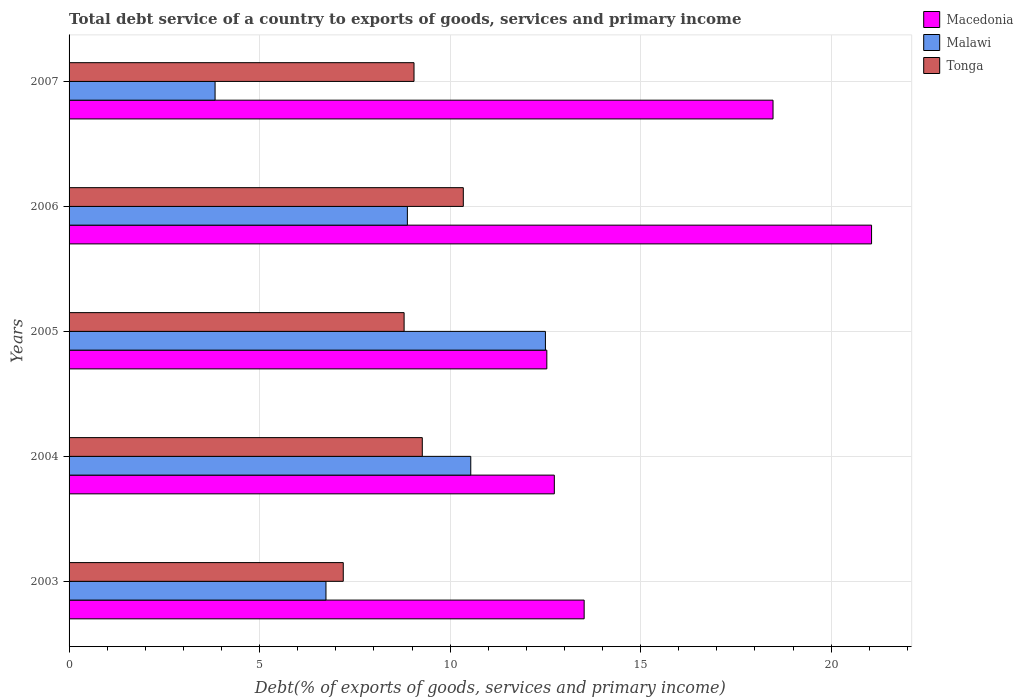Are the number of bars per tick equal to the number of legend labels?
Provide a succinct answer. Yes. How many bars are there on the 1st tick from the top?
Keep it short and to the point. 3. How many bars are there on the 1st tick from the bottom?
Your response must be concise. 3. In how many cases, is the number of bars for a given year not equal to the number of legend labels?
Your response must be concise. 0. What is the total debt service in Tonga in 2007?
Offer a very short reply. 9.05. Across all years, what is the maximum total debt service in Tonga?
Provide a succinct answer. 10.35. Across all years, what is the minimum total debt service in Malawi?
Your answer should be very brief. 3.83. In which year was the total debt service in Malawi maximum?
Give a very brief answer. 2005. What is the total total debt service in Macedonia in the graph?
Keep it short and to the point. 78.33. What is the difference between the total debt service in Malawi in 2004 and that in 2005?
Provide a succinct answer. -1.96. What is the difference between the total debt service in Malawi in 2005 and the total debt service in Tonga in 2007?
Your answer should be very brief. 3.45. What is the average total debt service in Tonga per year?
Your answer should be compact. 8.93. In the year 2007, what is the difference between the total debt service in Tonga and total debt service in Macedonia?
Give a very brief answer. -9.42. In how many years, is the total debt service in Tonga greater than 6 %?
Provide a succinct answer. 5. What is the ratio of the total debt service in Macedonia in 2004 to that in 2005?
Make the answer very short. 1.02. What is the difference between the highest and the second highest total debt service in Macedonia?
Ensure brevity in your answer.  2.59. What is the difference between the highest and the lowest total debt service in Macedonia?
Keep it short and to the point. 8.52. In how many years, is the total debt service in Macedonia greater than the average total debt service in Macedonia taken over all years?
Make the answer very short. 2. What does the 1st bar from the top in 2006 represents?
Your answer should be compact. Tonga. What does the 1st bar from the bottom in 2003 represents?
Offer a very short reply. Macedonia. Is it the case that in every year, the sum of the total debt service in Tonga and total debt service in Malawi is greater than the total debt service in Macedonia?
Offer a terse response. No. Are all the bars in the graph horizontal?
Ensure brevity in your answer.  Yes. What is the difference between two consecutive major ticks on the X-axis?
Make the answer very short. 5. Are the values on the major ticks of X-axis written in scientific E-notation?
Provide a short and direct response. No. Does the graph contain any zero values?
Provide a succinct answer. No. Does the graph contain grids?
Offer a very short reply. Yes. How are the legend labels stacked?
Offer a very short reply. Vertical. What is the title of the graph?
Give a very brief answer. Total debt service of a country to exports of goods, services and primary income. What is the label or title of the X-axis?
Your answer should be compact. Debt(% of exports of goods, services and primary income). What is the Debt(% of exports of goods, services and primary income) in Macedonia in 2003?
Keep it short and to the point. 13.52. What is the Debt(% of exports of goods, services and primary income) of Malawi in 2003?
Your response must be concise. 6.74. What is the Debt(% of exports of goods, services and primary income) of Tonga in 2003?
Make the answer very short. 7.2. What is the Debt(% of exports of goods, services and primary income) in Macedonia in 2004?
Your response must be concise. 12.74. What is the Debt(% of exports of goods, services and primary income) in Malawi in 2004?
Offer a terse response. 10.54. What is the Debt(% of exports of goods, services and primary income) in Tonga in 2004?
Keep it short and to the point. 9.27. What is the Debt(% of exports of goods, services and primary income) in Macedonia in 2005?
Your answer should be compact. 12.54. What is the Debt(% of exports of goods, services and primary income) of Malawi in 2005?
Offer a terse response. 12.5. What is the Debt(% of exports of goods, services and primary income) of Tonga in 2005?
Provide a short and direct response. 8.79. What is the Debt(% of exports of goods, services and primary income) in Macedonia in 2006?
Provide a short and direct response. 21.06. What is the Debt(% of exports of goods, services and primary income) in Malawi in 2006?
Give a very brief answer. 8.88. What is the Debt(% of exports of goods, services and primary income) of Tonga in 2006?
Your answer should be compact. 10.35. What is the Debt(% of exports of goods, services and primary income) in Macedonia in 2007?
Keep it short and to the point. 18.47. What is the Debt(% of exports of goods, services and primary income) of Malawi in 2007?
Your response must be concise. 3.83. What is the Debt(% of exports of goods, services and primary income) in Tonga in 2007?
Provide a succinct answer. 9.05. Across all years, what is the maximum Debt(% of exports of goods, services and primary income) of Macedonia?
Offer a very short reply. 21.06. Across all years, what is the maximum Debt(% of exports of goods, services and primary income) of Malawi?
Ensure brevity in your answer.  12.5. Across all years, what is the maximum Debt(% of exports of goods, services and primary income) in Tonga?
Keep it short and to the point. 10.35. Across all years, what is the minimum Debt(% of exports of goods, services and primary income) in Macedonia?
Offer a terse response. 12.54. Across all years, what is the minimum Debt(% of exports of goods, services and primary income) in Malawi?
Keep it short and to the point. 3.83. Across all years, what is the minimum Debt(% of exports of goods, services and primary income) in Tonga?
Make the answer very short. 7.2. What is the total Debt(% of exports of goods, services and primary income) of Macedonia in the graph?
Give a very brief answer. 78.33. What is the total Debt(% of exports of goods, services and primary income) in Malawi in the graph?
Provide a succinct answer. 42.5. What is the total Debt(% of exports of goods, services and primary income) in Tonga in the graph?
Ensure brevity in your answer.  44.66. What is the difference between the Debt(% of exports of goods, services and primary income) of Macedonia in 2003 and that in 2004?
Offer a terse response. 0.78. What is the difference between the Debt(% of exports of goods, services and primary income) of Malawi in 2003 and that in 2004?
Give a very brief answer. -3.8. What is the difference between the Debt(% of exports of goods, services and primary income) in Tonga in 2003 and that in 2004?
Offer a very short reply. -2.07. What is the difference between the Debt(% of exports of goods, services and primary income) of Macedonia in 2003 and that in 2005?
Offer a very short reply. 0.98. What is the difference between the Debt(% of exports of goods, services and primary income) of Malawi in 2003 and that in 2005?
Ensure brevity in your answer.  -5.76. What is the difference between the Debt(% of exports of goods, services and primary income) in Tonga in 2003 and that in 2005?
Offer a terse response. -1.6. What is the difference between the Debt(% of exports of goods, services and primary income) of Macedonia in 2003 and that in 2006?
Offer a terse response. -7.54. What is the difference between the Debt(% of exports of goods, services and primary income) of Malawi in 2003 and that in 2006?
Provide a short and direct response. -2.14. What is the difference between the Debt(% of exports of goods, services and primary income) of Tonga in 2003 and that in 2006?
Keep it short and to the point. -3.15. What is the difference between the Debt(% of exports of goods, services and primary income) in Macedonia in 2003 and that in 2007?
Offer a very short reply. -4.96. What is the difference between the Debt(% of exports of goods, services and primary income) of Malawi in 2003 and that in 2007?
Make the answer very short. 2.91. What is the difference between the Debt(% of exports of goods, services and primary income) in Tonga in 2003 and that in 2007?
Your response must be concise. -1.86. What is the difference between the Debt(% of exports of goods, services and primary income) of Macedonia in 2004 and that in 2005?
Provide a short and direct response. 0.2. What is the difference between the Debt(% of exports of goods, services and primary income) of Malawi in 2004 and that in 2005?
Ensure brevity in your answer.  -1.96. What is the difference between the Debt(% of exports of goods, services and primary income) in Tonga in 2004 and that in 2005?
Give a very brief answer. 0.48. What is the difference between the Debt(% of exports of goods, services and primary income) of Macedonia in 2004 and that in 2006?
Your answer should be compact. -8.33. What is the difference between the Debt(% of exports of goods, services and primary income) of Malawi in 2004 and that in 2006?
Give a very brief answer. 1.66. What is the difference between the Debt(% of exports of goods, services and primary income) in Tonga in 2004 and that in 2006?
Offer a very short reply. -1.08. What is the difference between the Debt(% of exports of goods, services and primary income) of Macedonia in 2004 and that in 2007?
Offer a terse response. -5.74. What is the difference between the Debt(% of exports of goods, services and primary income) of Malawi in 2004 and that in 2007?
Provide a succinct answer. 6.71. What is the difference between the Debt(% of exports of goods, services and primary income) of Tonga in 2004 and that in 2007?
Give a very brief answer. 0.22. What is the difference between the Debt(% of exports of goods, services and primary income) in Macedonia in 2005 and that in 2006?
Your answer should be very brief. -8.52. What is the difference between the Debt(% of exports of goods, services and primary income) of Malawi in 2005 and that in 2006?
Your answer should be very brief. 3.62. What is the difference between the Debt(% of exports of goods, services and primary income) in Tonga in 2005 and that in 2006?
Provide a short and direct response. -1.55. What is the difference between the Debt(% of exports of goods, services and primary income) of Macedonia in 2005 and that in 2007?
Offer a terse response. -5.94. What is the difference between the Debt(% of exports of goods, services and primary income) of Malawi in 2005 and that in 2007?
Make the answer very short. 8.67. What is the difference between the Debt(% of exports of goods, services and primary income) of Tonga in 2005 and that in 2007?
Give a very brief answer. -0.26. What is the difference between the Debt(% of exports of goods, services and primary income) of Macedonia in 2006 and that in 2007?
Ensure brevity in your answer.  2.59. What is the difference between the Debt(% of exports of goods, services and primary income) of Malawi in 2006 and that in 2007?
Offer a terse response. 5.05. What is the difference between the Debt(% of exports of goods, services and primary income) in Tonga in 2006 and that in 2007?
Provide a short and direct response. 1.29. What is the difference between the Debt(% of exports of goods, services and primary income) in Macedonia in 2003 and the Debt(% of exports of goods, services and primary income) in Malawi in 2004?
Offer a very short reply. 2.98. What is the difference between the Debt(% of exports of goods, services and primary income) of Macedonia in 2003 and the Debt(% of exports of goods, services and primary income) of Tonga in 2004?
Provide a succinct answer. 4.25. What is the difference between the Debt(% of exports of goods, services and primary income) in Malawi in 2003 and the Debt(% of exports of goods, services and primary income) in Tonga in 2004?
Offer a terse response. -2.53. What is the difference between the Debt(% of exports of goods, services and primary income) in Macedonia in 2003 and the Debt(% of exports of goods, services and primary income) in Malawi in 2005?
Give a very brief answer. 1.02. What is the difference between the Debt(% of exports of goods, services and primary income) in Macedonia in 2003 and the Debt(% of exports of goods, services and primary income) in Tonga in 2005?
Offer a terse response. 4.73. What is the difference between the Debt(% of exports of goods, services and primary income) in Malawi in 2003 and the Debt(% of exports of goods, services and primary income) in Tonga in 2005?
Provide a short and direct response. -2.05. What is the difference between the Debt(% of exports of goods, services and primary income) of Macedonia in 2003 and the Debt(% of exports of goods, services and primary income) of Malawi in 2006?
Ensure brevity in your answer.  4.64. What is the difference between the Debt(% of exports of goods, services and primary income) in Macedonia in 2003 and the Debt(% of exports of goods, services and primary income) in Tonga in 2006?
Your response must be concise. 3.17. What is the difference between the Debt(% of exports of goods, services and primary income) of Malawi in 2003 and the Debt(% of exports of goods, services and primary income) of Tonga in 2006?
Offer a very short reply. -3.6. What is the difference between the Debt(% of exports of goods, services and primary income) of Macedonia in 2003 and the Debt(% of exports of goods, services and primary income) of Malawi in 2007?
Offer a very short reply. 9.69. What is the difference between the Debt(% of exports of goods, services and primary income) in Macedonia in 2003 and the Debt(% of exports of goods, services and primary income) in Tonga in 2007?
Keep it short and to the point. 4.46. What is the difference between the Debt(% of exports of goods, services and primary income) in Malawi in 2003 and the Debt(% of exports of goods, services and primary income) in Tonga in 2007?
Your answer should be compact. -2.31. What is the difference between the Debt(% of exports of goods, services and primary income) of Macedonia in 2004 and the Debt(% of exports of goods, services and primary income) of Malawi in 2005?
Offer a very short reply. 0.23. What is the difference between the Debt(% of exports of goods, services and primary income) of Macedonia in 2004 and the Debt(% of exports of goods, services and primary income) of Tonga in 2005?
Keep it short and to the point. 3.94. What is the difference between the Debt(% of exports of goods, services and primary income) of Malawi in 2004 and the Debt(% of exports of goods, services and primary income) of Tonga in 2005?
Give a very brief answer. 1.75. What is the difference between the Debt(% of exports of goods, services and primary income) in Macedonia in 2004 and the Debt(% of exports of goods, services and primary income) in Malawi in 2006?
Give a very brief answer. 3.86. What is the difference between the Debt(% of exports of goods, services and primary income) of Macedonia in 2004 and the Debt(% of exports of goods, services and primary income) of Tonga in 2006?
Give a very brief answer. 2.39. What is the difference between the Debt(% of exports of goods, services and primary income) in Malawi in 2004 and the Debt(% of exports of goods, services and primary income) in Tonga in 2006?
Your response must be concise. 0.2. What is the difference between the Debt(% of exports of goods, services and primary income) of Macedonia in 2004 and the Debt(% of exports of goods, services and primary income) of Malawi in 2007?
Ensure brevity in your answer.  8.9. What is the difference between the Debt(% of exports of goods, services and primary income) of Macedonia in 2004 and the Debt(% of exports of goods, services and primary income) of Tonga in 2007?
Make the answer very short. 3.68. What is the difference between the Debt(% of exports of goods, services and primary income) in Malawi in 2004 and the Debt(% of exports of goods, services and primary income) in Tonga in 2007?
Offer a very short reply. 1.49. What is the difference between the Debt(% of exports of goods, services and primary income) of Macedonia in 2005 and the Debt(% of exports of goods, services and primary income) of Malawi in 2006?
Your answer should be compact. 3.66. What is the difference between the Debt(% of exports of goods, services and primary income) in Macedonia in 2005 and the Debt(% of exports of goods, services and primary income) in Tonga in 2006?
Offer a terse response. 2.19. What is the difference between the Debt(% of exports of goods, services and primary income) in Malawi in 2005 and the Debt(% of exports of goods, services and primary income) in Tonga in 2006?
Make the answer very short. 2.15. What is the difference between the Debt(% of exports of goods, services and primary income) in Macedonia in 2005 and the Debt(% of exports of goods, services and primary income) in Malawi in 2007?
Provide a succinct answer. 8.71. What is the difference between the Debt(% of exports of goods, services and primary income) in Macedonia in 2005 and the Debt(% of exports of goods, services and primary income) in Tonga in 2007?
Provide a short and direct response. 3.49. What is the difference between the Debt(% of exports of goods, services and primary income) of Malawi in 2005 and the Debt(% of exports of goods, services and primary income) of Tonga in 2007?
Your answer should be compact. 3.45. What is the difference between the Debt(% of exports of goods, services and primary income) in Macedonia in 2006 and the Debt(% of exports of goods, services and primary income) in Malawi in 2007?
Offer a very short reply. 17.23. What is the difference between the Debt(% of exports of goods, services and primary income) in Macedonia in 2006 and the Debt(% of exports of goods, services and primary income) in Tonga in 2007?
Your answer should be very brief. 12.01. What is the difference between the Debt(% of exports of goods, services and primary income) in Malawi in 2006 and the Debt(% of exports of goods, services and primary income) in Tonga in 2007?
Offer a very short reply. -0.17. What is the average Debt(% of exports of goods, services and primary income) of Macedonia per year?
Provide a succinct answer. 15.67. What is the average Debt(% of exports of goods, services and primary income) in Malawi per year?
Provide a succinct answer. 8.5. What is the average Debt(% of exports of goods, services and primary income) of Tonga per year?
Your answer should be compact. 8.93. In the year 2003, what is the difference between the Debt(% of exports of goods, services and primary income) in Macedonia and Debt(% of exports of goods, services and primary income) in Malawi?
Provide a short and direct response. 6.78. In the year 2003, what is the difference between the Debt(% of exports of goods, services and primary income) in Macedonia and Debt(% of exports of goods, services and primary income) in Tonga?
Your answer should be compact. 6.32. In the year 2003, what is the difference between the Debt(% of exports of goods, services and primary income) of Malawi and Debt(% of exports of goods, services and primary income) of Tonga?
Offer a terse response. -0.45. In the year 2004, what is the difference between the Debt(% of exports of goods, services and primary income) in Macedonia and Debt(% of exports of goods, services and primary income) in Malawi?
Make the answer very short. 2.19. In the year 2004, what is the difference between the Debt(% of exports of goods, services and primary income) in Macedonia and Debt(% of exports of goods, services and primary income) in Tonga?
Make the answer very short. 3.46. In the year 2004, what is the difference between the Debt(% of exports of goods, services and primary income) in Malawi and Debt(% of exports of goods, services and primary income) in Tonga?
Keep it short and to the point. 1.27. In the year 2005, what is the difference between the Debt(% of exports of goods, services and primary income) of Macedonia and Debt(% of exports of goods, services and primary income) of Malawi?
Provide a short and direct response. 0.04. In the year 2005, what is the difference between the Debt(% of exports of goods, services and primary income) in Macedonia and Debt(% of exports of goods, services and primary income) in Tonga?
Your answer should be very brief. 3.75. In the year 2005, what is the difference between the Debt(% of exports of goods, services and primary income) of Malawi and Debt(% of exports of goods, services and primary income) of Tonga?
Offer a very short reply. 3.71. In the year 2006, what is the difference between the Debt(% of exports of goods, services and primary income) in Macedonia and Debt(% of exports of goods, services and primary income) in Malawi?
Your response must be concise. 12.18. In the year 2006, what is the difference between the Debt(% of exports of goods, services and primary income) of Macedonia and Debt(% of exports of goods, services and primary income) of Tonga?
Provide a succinct answer. 10.71. In the year 2006, what is the difference between the Debt(% of exports of goods, services and primary income) in Malawi and Debt(% of exports of goods, services and primary income) in Tonga?
Give a very brief answer. -1.47. In the year 2007, what is the difference between the Debt(% of exports of goods, services and primary income) in Macedonia and Debt(% of exports of goods, services and primary income) in Malawi?
Your response must be concise. 14.64. In the year 2007, what is the difference between the Debt(% of exports of goods, services and primary income) of Macedonia and Debt(% of exports of goods, services and primary income) of Tonga?
Keep it short and to the point. 9.42. In the year 2007, what is the difference between the Debt(% of exports of goods, services and primary income) of Malawi and Debt(% of exports of goods, services and primary income) of Tonga?
Provide a succinct answer. -5.22. What is the ratio of the Debt(% of exports of goods, services and primary income) of Macedonia in 2003 to that in 2004?
Your answer should be very brief. 1.06. What is the ratio of the Debt(% of exports of goods, services and primary income) of Malawi in 2003 to that in 2004?
Keep it short and to the point. 0.64. What is the ratio of the Debt(% of exports of goods, services and primary income) in Tonga in 2003 to that in 2004?
Keep it short and to the point. 0.78. What is the ratio of the Debt(% of exports of goods, services and primary income) in Macedonia in 2003 to that in 2005?
Offer a terse response. 1.08. What is the ratio of the Debt(% of exports of goods, services and primary income) of Malawi in 2003 to that in 2005?
Provide a short and direct response. 0.54. What is the ratio of the Debt(% of exports of goods, services and primary income) of Tonga in 2003 to that in 2005?
Offer a very short reply. 0.82. What is the ratio of the Debt(% of exports of goods, services and primary income) of Macedonia in 2003 to that in 2006?
Offer a very short reply. 0.64. What is the ratio of the Debt(% of exports of goods, services and primary income) in Malawi in 2003 to that in 2006?
Give a very brief answer. 0.76. What is the ratio of the Debt(% of exports of goods, services and primary income) of Tonga in 2003 to that in 2006?
Make the answer very short. 0.7. What is the ratio of the Debt(% of exports of goods, services and primary income) in Macedonia in 2003 to that in 2007?
Provide a short and direct response. 0.73. What is the ratio of the Debt(% of exports of goods, services and primary income) of Malawi in 2003 to that in 2007?
Make the answer very short. 1.76. What is the ratio of the Debt(% of exports of goods, services and primary income) in Tonga in 2003 to that in 2007?
Your response must be concise. 0.79. What is the ratio of the Debt(% of exports of goods, services and primary income) in Macedonia in 2004 to that in 2005?
Your answer should be very brief. 1.02. What is the ratio of the Debt(% of exports of goods, services and primary income) of Malawi in 2004 to that in 2005?
Your answer should be very brief. 0.84. What is the ratio of the Debt(% of exports of goods, services and primary income) in Tonga in 2004 to that in 2005?
Your answer should be compact. 1.05. What is the ratio of the Debt(% of exports of goods, services and primary income) of Macedonia in 2004 to that in 2006?
Your answer should be very brief. 0.6. What is the ratio of the Debt(% of exports of goods, services and primary income) of Malawi in 2004 to that in 2006?
Offer a very short reply. 1.19. What is the ratio of the Debt(% of exports of goods, services and primary income) in Tonga in 2004 to that in 2006?
Offer a terse response. 0.9. What is the ratio of the Debt(% of exports of goods, services and primary income) of Macedonia in 2004 to that in 2007?
Give a very brief answer. 0.69. What is the ratio of the Debt(% of exports of goods, services and primary income) in Malawi in 2004 to that in 2007?
Ensure brevity in your answer.  2.75. What is the ratio of the Debt(% of exports of goods, services and primary income) in Macedonia in 2005 to that in 2006?
Your response must be concise. 0.6. What is the ratio of the Debt(% of exports of goods, services and primary income) of Malawi in 2005 to that in 2006?
Give a very brief answer. 1.41. What is the ratio of the Debt(% of exports of goods, services and primary income) in Tonga in 2005 to that in 2006?
Keep it short and to the point. 0.85. What is the ratio of the Debt(% of exports of goods, services and primary income) in Macedonia in 2005 to that in 2007?
Ensure brevity in your answer.  0.68. What is the ratio of the Debt(% of exports of goods, services and primary income) of Malawi in 2005 to that in 2007?
Offer a terse response. 3.26. What is the ratio of the Debt(% of exports of goods, services and primary income) in Tonga in 2005 to that in 2007?
Your response must be concise. 0.97. What is the ratio of the Debt(% of exports of goods, services and primary income) of Macedonia in 2006 to that in 2007?
Your response must be concise. 1.14. What is the ratio of the Debt(% of exports of goods, services and primary income) of Malawi in 2006 to that in 2007?
Provide a short and direct response. 2.32. What is the ratio of the Debt(% of exports of goods, services and primary income) in Tonga in 2006 to that in 2007?
Your answer should be compact. 1.14. What is the difference between the highest and the second highest Debt(% of exports of goods, services and primary income) in Macedonia?
Make the answer very short. 2.59. What is the difference between the highest and the second highest Debt(% of exports of goods, services and primary income) of Malawi?
Provide a short and direct response. 1.96. What is the difference between the highest and the second highest Debt(% of exports of goods, services and primary income) of Tonga?
Keep it short and to the point. 1.08. What is the difference between the highest and the lowest Debt(% of exports of goods, services and primary income) of Macedonia?
Make the answer very short. 8.52. What is the difference between the highest and the lowest Debt(% of exports of goods, services and primary income) in Malawi?
Your answer should be compact. 8.67. What is the difference between the highest and the lowest Debt(% of exports of goods, services and primary income) in Tonga?
Offer a terse response. 3.15. 